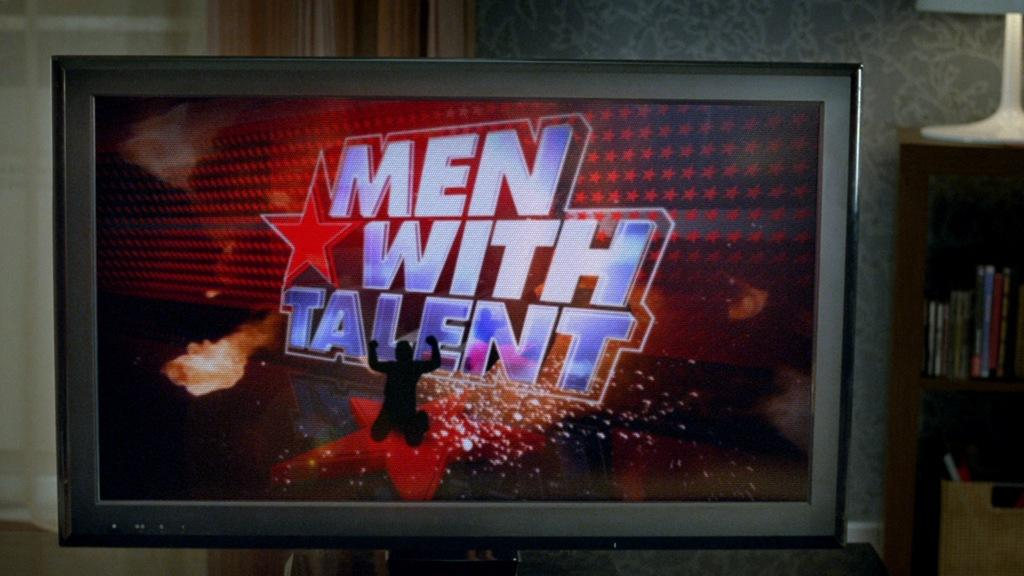<image>
Create a compact narrative representing the image presented. a television with a men with talent logo on it 